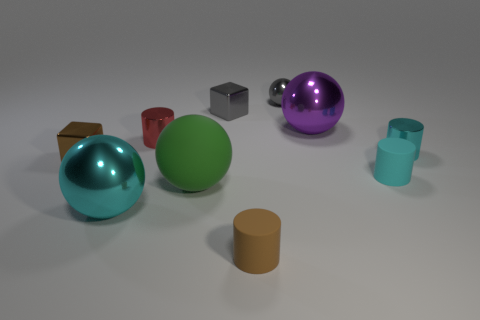What number of objects are red objects or large yellow matte blocks?
Keep it short and to the point. 1. Is the number of brown blocks that are on the left side of the brown metallic object the same as the number of small cyan cylinders?
Provide a succinct answer. No. Is there a brown thing behind the cyan sphere in front of the small cube behind the tiny red shiny cylinder?
Offer a terse response. Yes. What is the color of the other tiny cylinder that is the same material as the red cylinder?
Provide a succinct answer. Cyan. There is a metallic cube that is on the right side of the small red shiny thing; does it have the same color as the small metal ball?
Keep it short and to the point. Yes. What number of blocks are tiny brown objects or small blue matte things?
Offer a terse response. 1. There is a metallic sphere that is to the left of the small shiny cube that is behind the cylinder left of the big green ball; how big is it?
Ensure brevity in your answer.  Large. There is a matte thing that is the same size as the purple metallic sphere; what shape is it?
Offer a very short reply. Sphere. The red thing has what shape?
Provide a succinct answer. Cylinder. Is the small cube that is right of the large green thing made of the same material as the brown cylinder?
Your answer should be very brief. No. 